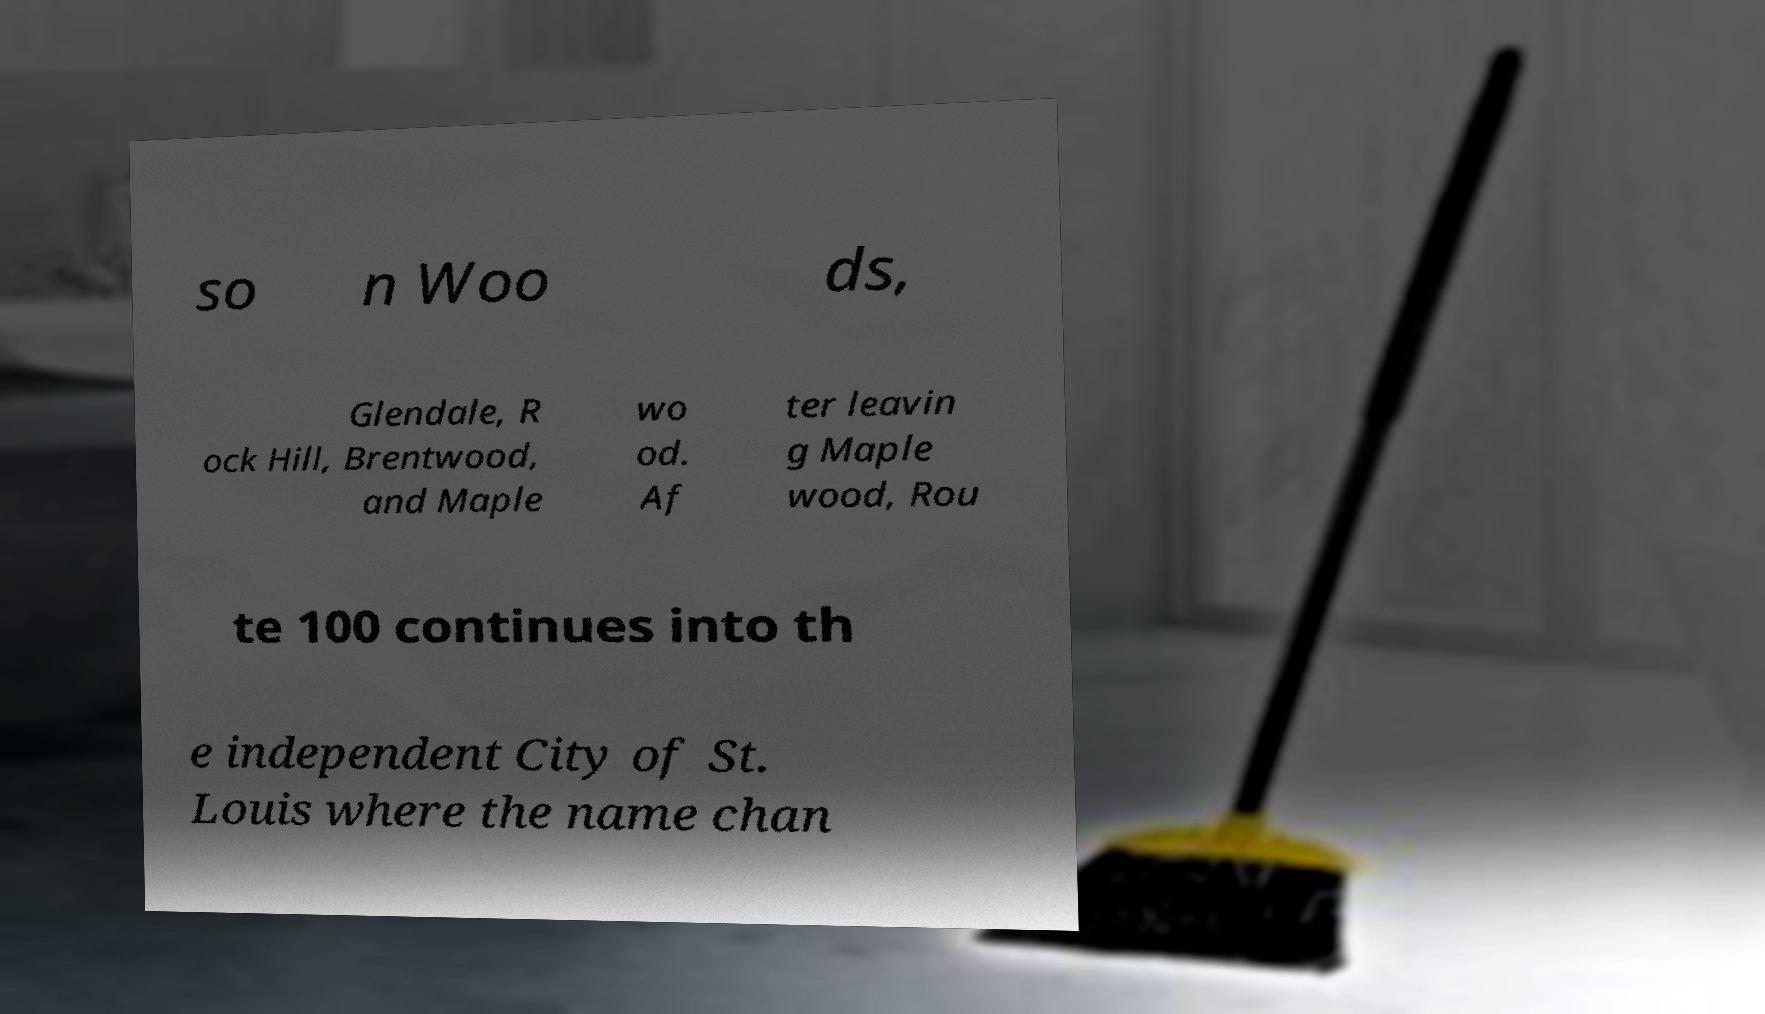For documentation purposes, I need the text within this image transcribed. Could you provide that? so n Woo ds, Glendale, R ock Hill, Brentwood, and Maple wo od. Af ter leavin g Maple wood, Rou te 100 continues into th e independent City of St. Louis where the name chan 